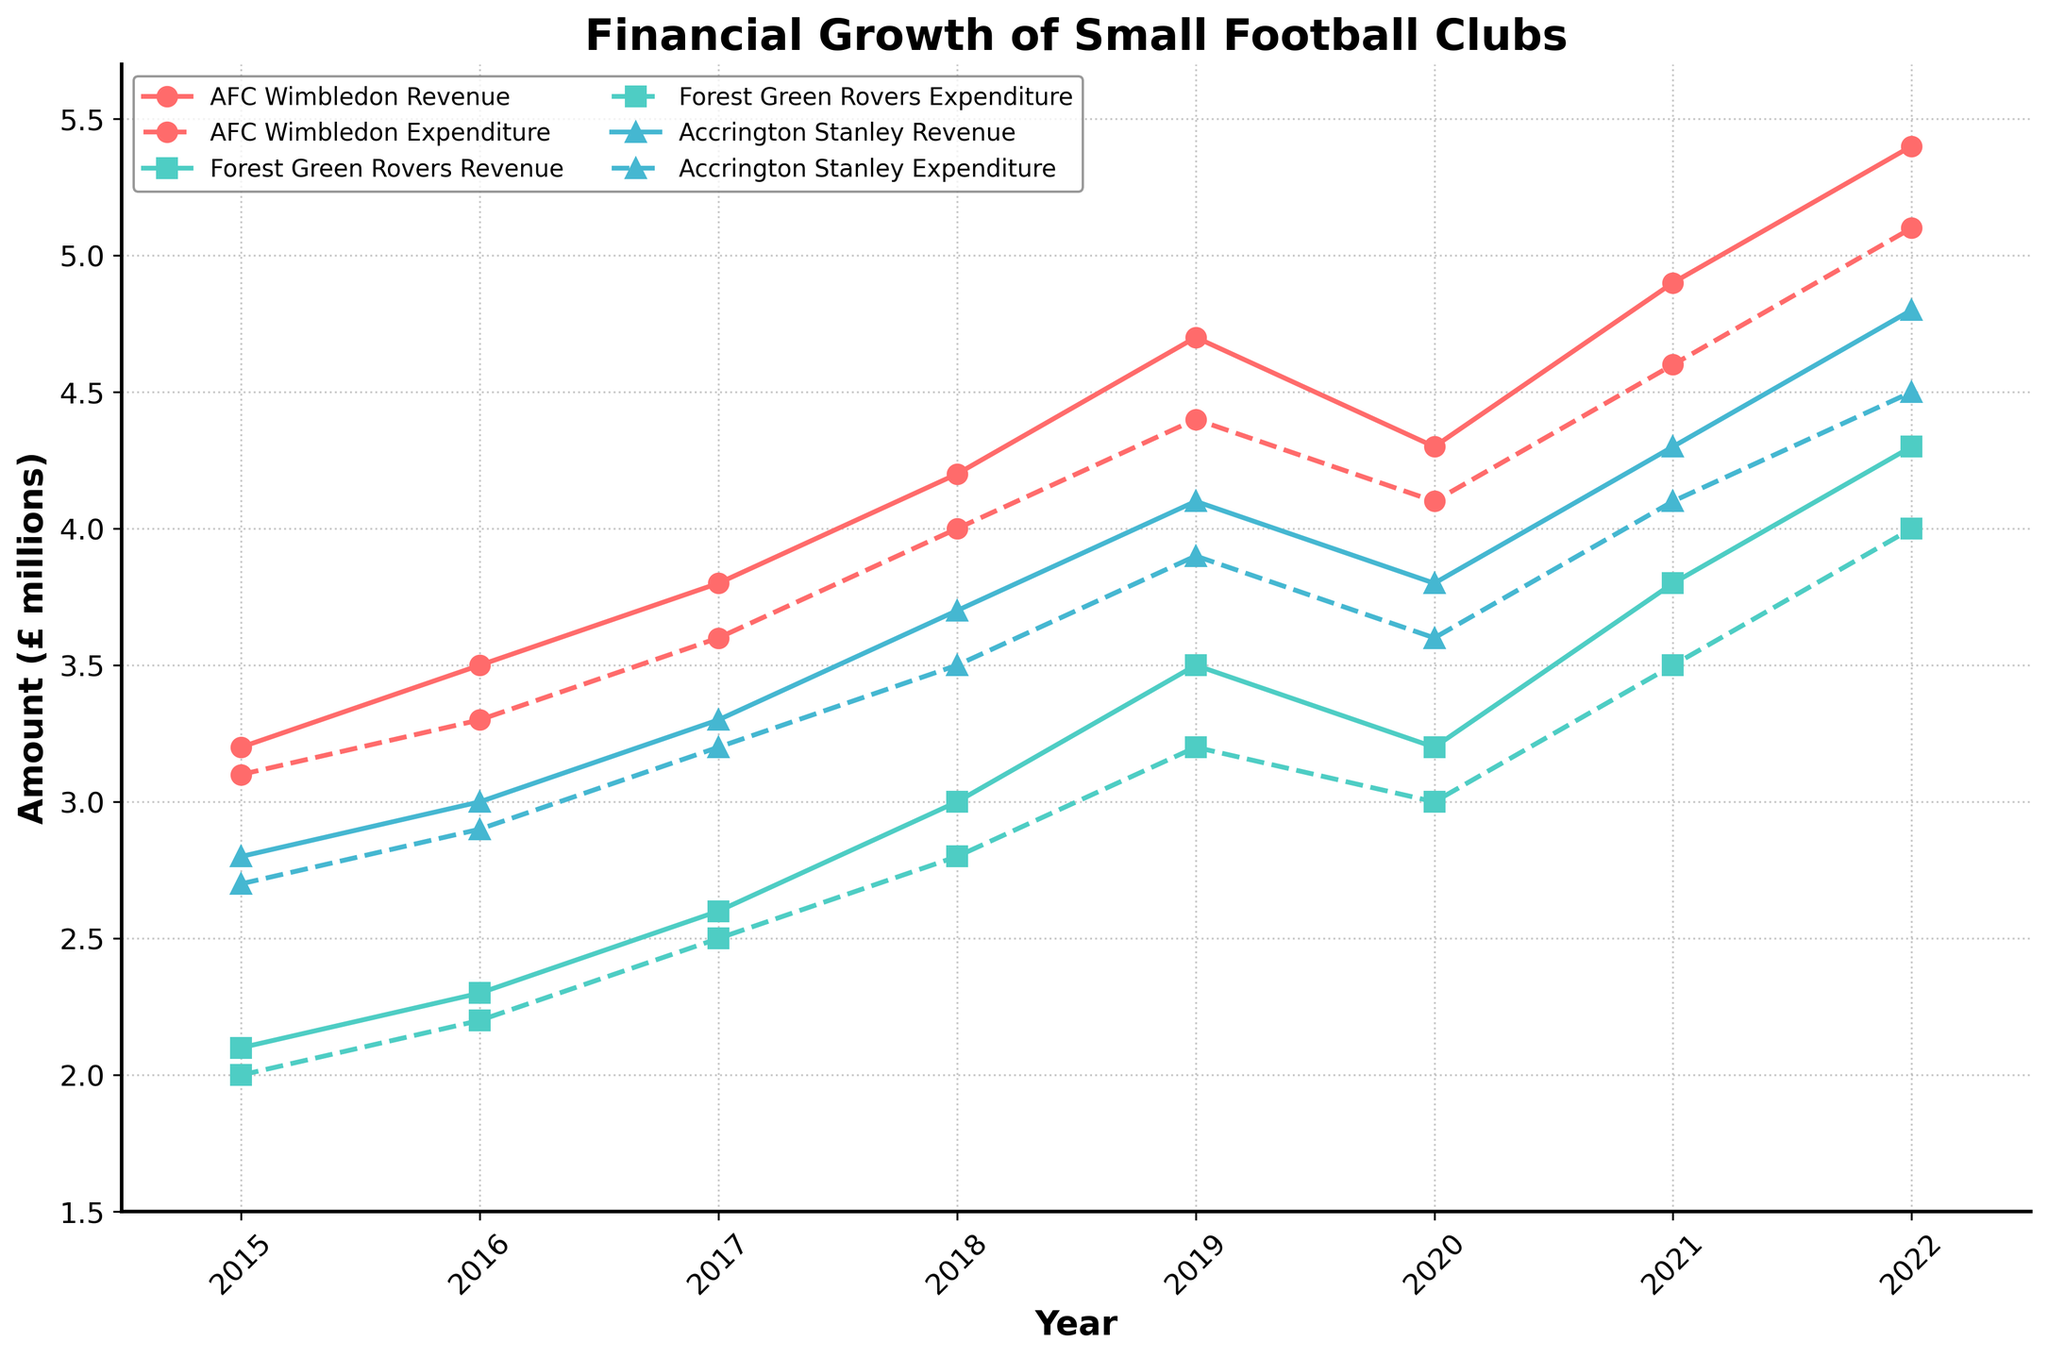What was the highest revenue among all the clubs in 2022? The highest value in the 'Revenue' data series for 2022 is AFC Wimbledon with £5.4 million. By comparing against the other clubs, Forest Green Rovers had £4.3 million and Accrington Stanley had £4.8 million.
Answer: £5.4 million How did the expenditure of Accrington Stanley change from 2020 to 2021? Accrington Stanley's expenditure in 2020 was £3.6 million, and it increased to £4.1 million in 2021. The change in expenditure can be calculated as £4.1 million - £3.6 million = £0.5 million increase.
Answer: Increased by £0.5 million Which club had the smallest difference between revenue and expenditure in 2019? In 2019, the revenue and expenditure were as follows: AFC Wimbledon: £4.7 million - £4.4 million = £0.3 million; Forest Green Rovers: £3.5 million - £3.2 million = £0.3 million; Accrington Stanley: £4.1 million - £3.9 million = £0.2 million. Accrington Stanley had the smallest difference.
Answer: Accrington Stanley What was the average revenue of Forest Green Rovers from 2015 to 2020? Sum the revenues from 2015 to 2020 for Forest Green Rovers (2.1 + 2.3 + 2.6 + 3.0 + 3.5 + 3.2), which equals 16.7. The average is then 16.7 / 6 = 2.783 million.
Answer: £2.783 million Between which years did AFC Wimbledon see the largest increase in revenue? By calculating the difference year by year, we see: 2015-16: £0.3 million, 2016-17: £0.3 million, 2017-18: £0.4 million, 2018-19: £0.5 million, 2019-20: -£0.4 million, 2020-21: £0.6 million, 2021-22: £0.5 million. The largest increase was from 2020 to 2021 with £0.6 million.
Answer: 2020 to 2021 What trends do you observe in the revenue of Forest Green Rovers over the time period? The revenue of Forest Green Rovers consistently increases from 2015 (£2.1 million) to 2019 (£3.5 million), then decreases slightly in 2020 (£3.2 million), and continues to rise again until 2022 (£4.3 million).
Answer: Increasing trend with a slight dip in 2020 Which club had the highest expenditure in 2016, and what was the amount? In 2016, expenditures were: AFC Wimbledon: £3.3 million, Forest Green Rovers: £2.2 million, Accrington Stanley: £2.9 million. AFC Wimbledon had the highest expenditure at £3.3 million.
Answer: AFC Wimbledon, £3.3 million Compare the financial growth of AFC Wimbledon and Accrington Stanley from 2015 to 2022. Which club saw a larger net increase in revenue? AFC Wimbledon's revenue in 2015 was £3.2 million and increased to £5.4 million in 2022, so the net increase is £5.4 million - £3.2 million = £2.2 million. Accrington Stanley's revenue in 2015 was £2.8 million and increased to £4.8 million in 2022, so the net increase is £4.8 million - £2.8 million = £2.0 million. AFC Wimbledon saw a larger net increase.
Answer: AFC Wimbledon, £2.2 million 